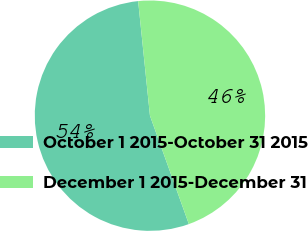Convert chart to OTSL. <chart><loc_0><loc_0><loc_500><loc_500><pie_chart><fcel>October 1 2015-October 31 2015<fcel>December 1 2015-December 31<nl><fcel>53.85%<fcel>46.15%<nl></chart> 